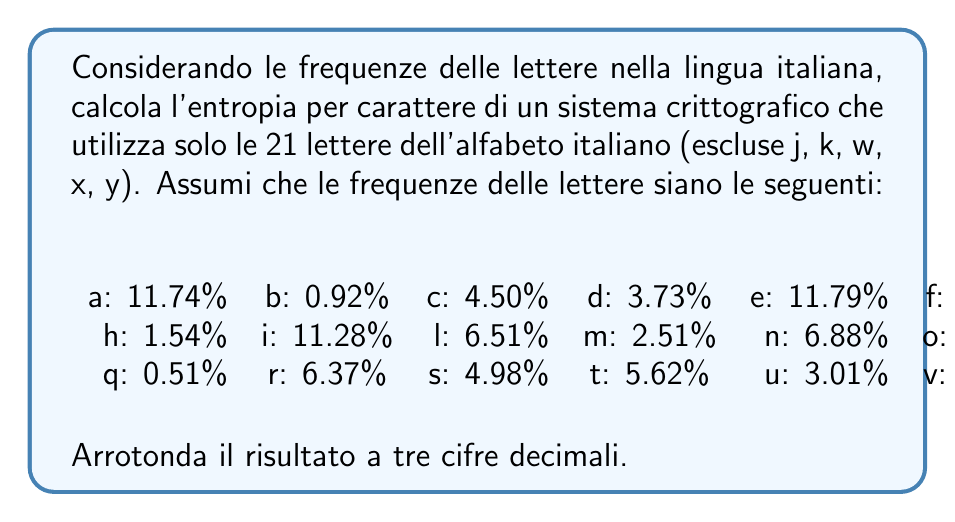Can you answer this question? Per calcolare l'entropia per carattere di questo sistema crittografico, useremo la formula dell'entropia di Shannon:

$$ H = -\sum_{i=1}^{n} p_i \log_2(p_i) $$

Dove $p_i$ è la probabilità di ciascun simbolo (in questo caso, la frequenza di ciascuna lettera) e $n$ è il numero totale di simboli (21 lettere).

Passi:

1) Convertiamo le percentuali in probabilità dividendo per 100:

   a: 0.1174, b: 0.0092, c: 0.0450, d: 0.0373, e: 0.1179, f: 0.0095, g: 0.0164, h: 0.0154, i: 0.1128, l: 0.0651, m: 0.0251, n: 0.0688, o: 0.0983, p: 0.0305, q: 0.0051, r: 0.0637, s: 0.0498, t: 0.0562, u: 0.0301, v: 0.0210, z: 0.0049

2) Per ogni lettera, calcoliamo $p_i \log_2(p_i)$:

   a: 0.1174 * log2(0.1174) = -0.3606
   b: 0.0092 * log2(0.0092) = -0.0443
   c: 0.0450 * log2(0.0450) = -0.1453
   ...
   z: 0.0049 * log2(0.0049) = -0.0258

3) Sommiamo tutti questi valori e moltiplichiamo per -1:

   $H = -(-0.3606 - 0.0443 - 0.1453 - ... - 0.0258)$

4) Calcolando la somma, otteniamo:

   $H = 4.0753$ bit per carattere

5) Arrotondiamo a tre cifre decimali:

   $H \approx 4.075$ bit per carattere
Answer: 4.075 bit per carattere 